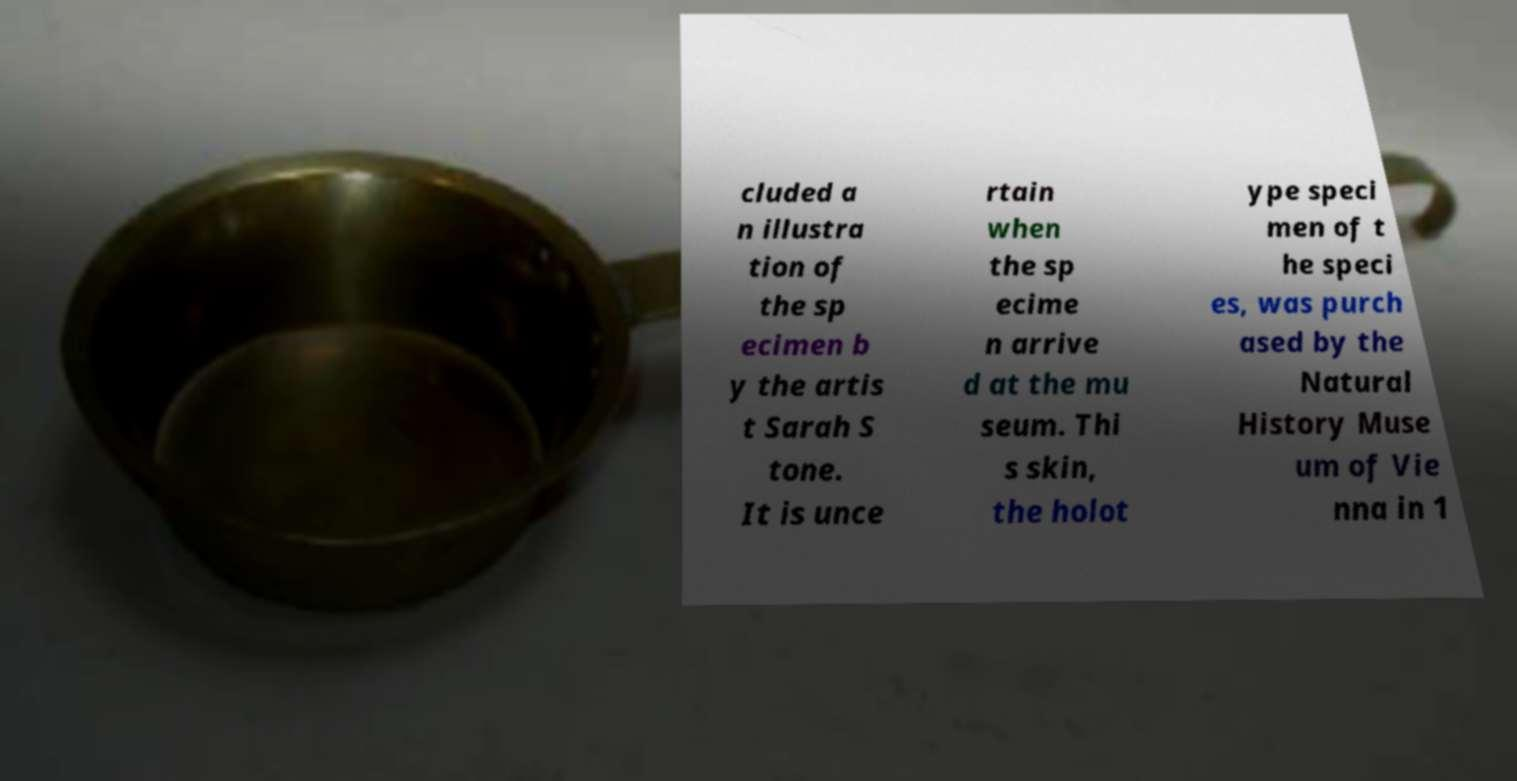I need the written content from this picture converted into text. Can you do that? cluded a n illustra tion of the sp ecimen b y the artis t Sarah S tone. It is unce rtain when the sp ecime n arrive d at the mu seum. Thi s skin, the holot ype speci men of t he speci es, was purch ased by the Natural History Muse um of Vie nna in 1 